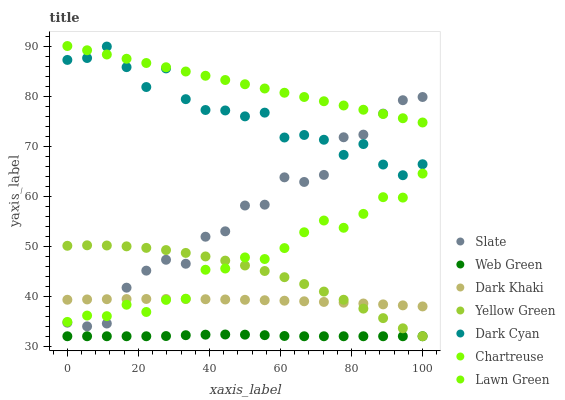Does Web Green have the minimum area under the curve?
Answer yes or no. Yes. Does Lawn Green have the maximum area under the curve?
Answer yes or no. Yes. Does Yellow Green have the minimum area under the curve?
Answer yes or no. No. Does Yellow Green have the maximum area under the curve?
Answer yes or no. No. Is Lawn Green the smoothest?
Answer yes or no. Yes. Is Slate the roughest?
Answer yes or no. Yes. Is Yellow Green the smoothest?
Answer yes or no. No. Is Yellow Green the roughest?
Answer yes or no. No. Does Yellow Green have the lowest value?
Answer yes or no. Yes. Does Slate have the lowest value?
Answer yes or no. No. Does Lawn Green have the highest value?
Answer yes or no. Yes. Does Yellow Green have the highest value?
Answer yes or no. No. Is Chartreuse less than Lawn Green?
Answer yes or no. Yes. Is Dark Cyan greater than Dark Khaki?
Answer yes or no. Yes. Does Dark Khaki intersect Yellow Green?
Answer yes or no. Yes. Is Dark Khaki less than Yellow Green?
Answer yes or no. No. Is Dark Khaki greater than Yellow Green?
Answer yes or no. No. Does Chartreuse intersect Lawn Green?
Answer yes or no. No. 